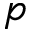<formula> <loc_0><loc_0><loc_500><loc_500>p</formula> 